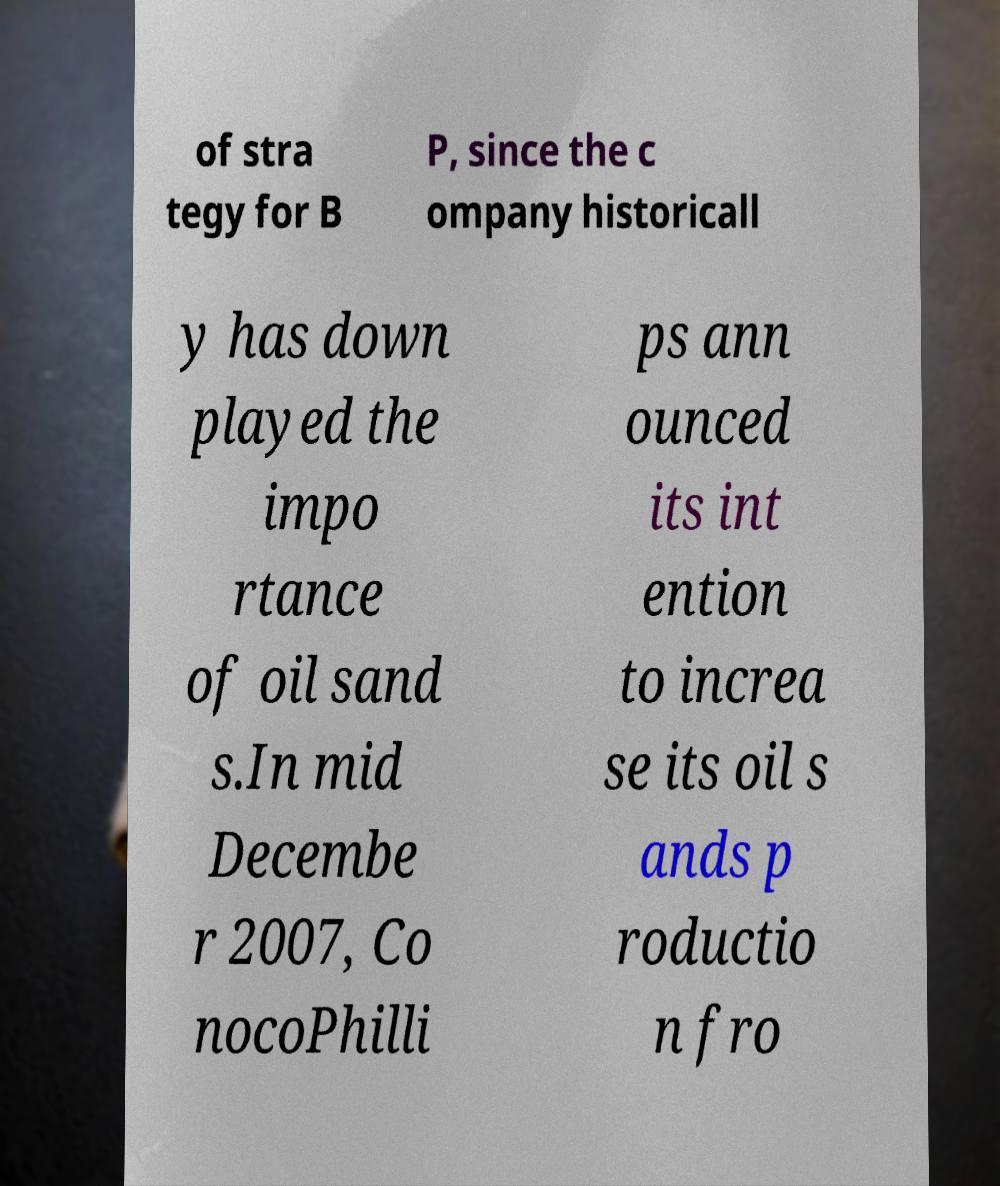There's text embedded in this image that I need extracted. Can you transcribe it verbatim? of stra tegy for B P, since the c ompany historicall y has down played the impo rtance of oil sand s.In mid Decembe r 2007, Co nocoPhilli ps ann ounced its int ention to increa se its oil s ands p roductio n fro 